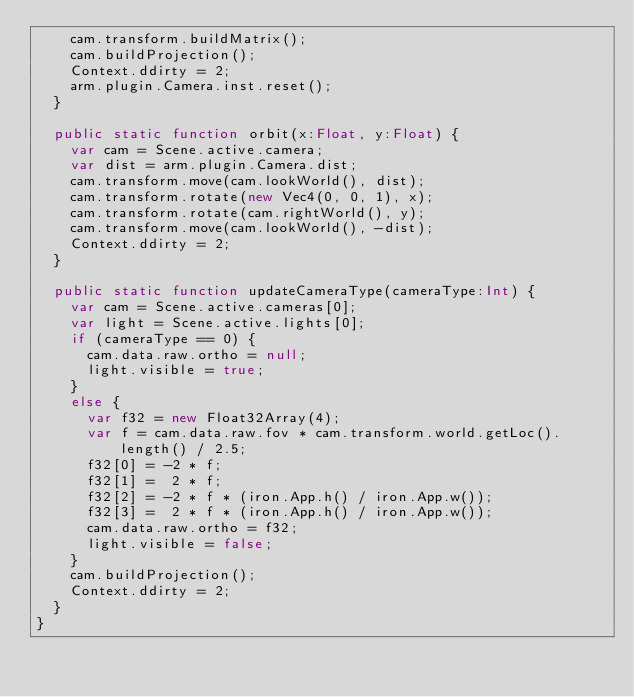<code> <loc_0><loc_0><loc_500><loc_500><_Haxe_>		cam.transform.buildMatrix();
		cam.buildProjection();
		Context.ddirty = 2;
		arm.plugin.Camera.inst.reset();
	}

	public static function orbit(x:Float, y:Float) {
		var cam = Scene.active.camera;
		var dist = arm.plugin.Camera.dist;
		cam.transform.move(cam.lookWorld(), dist);
		cam.transform.rotate(new Vec4(0, 0, 1), x);
		cam.transform.rotate(cam.rightWorld(), y);
		cam.transform.move(cam.lookWorld(), -dist);
		Context.ddirty = 2;
	}

	public static function updateCameraType(cameraType:Int) {
		var cam = Scene.active.cameras[0];
		var light = Scene.active.lights[0];
		if (cameraType == 0) {
			cam.data.raw.ortho = null;
			light.visible = true;
		}
		else {
			var f32 = new Float32Array(4);
			var f = cam.data.raw.fov * cam.transform.world.getLoc().length() / 2.5;
			f32[0] = -2 * f;
			f32[1] =  2 * f;
			f32[2] = -2 * f * (iron.App.h() / iron.App.w());
			f32[3] =  2 * f * (iron.App.h() / iron.App.w());
			cam.data.raw.ortho = f32;
			light.visible = false;
		}
		cam.buildProjection();
		Context.ddirty = 2;
	}
}
</code> 